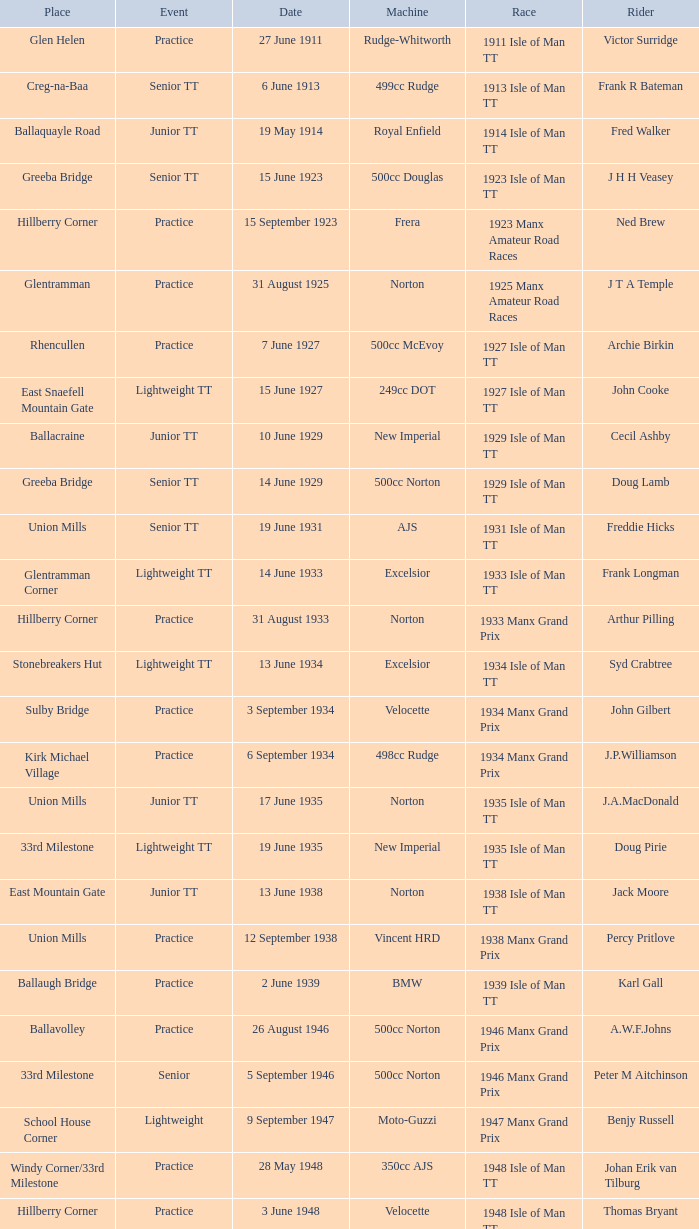What machine did Kenneth E. Herbert ride? 499cc Norton. 